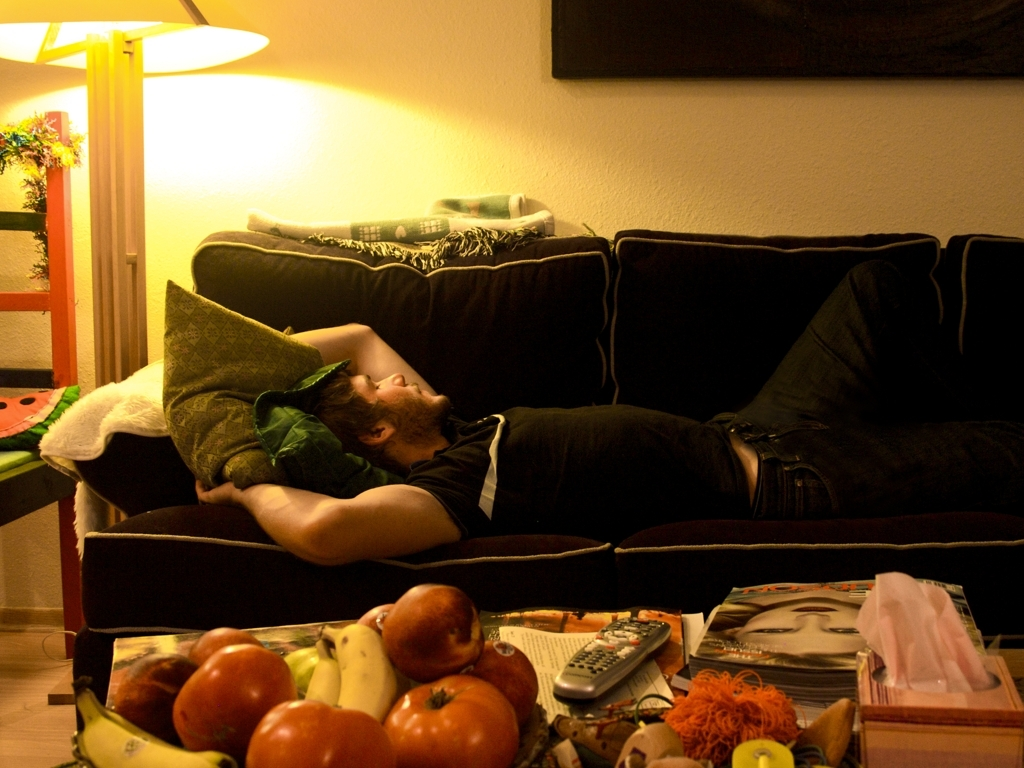Are the objects on the desktop sharply defined?
A. No
B. Yes
Answer with the option's letter from the given choices directly.
 B. 